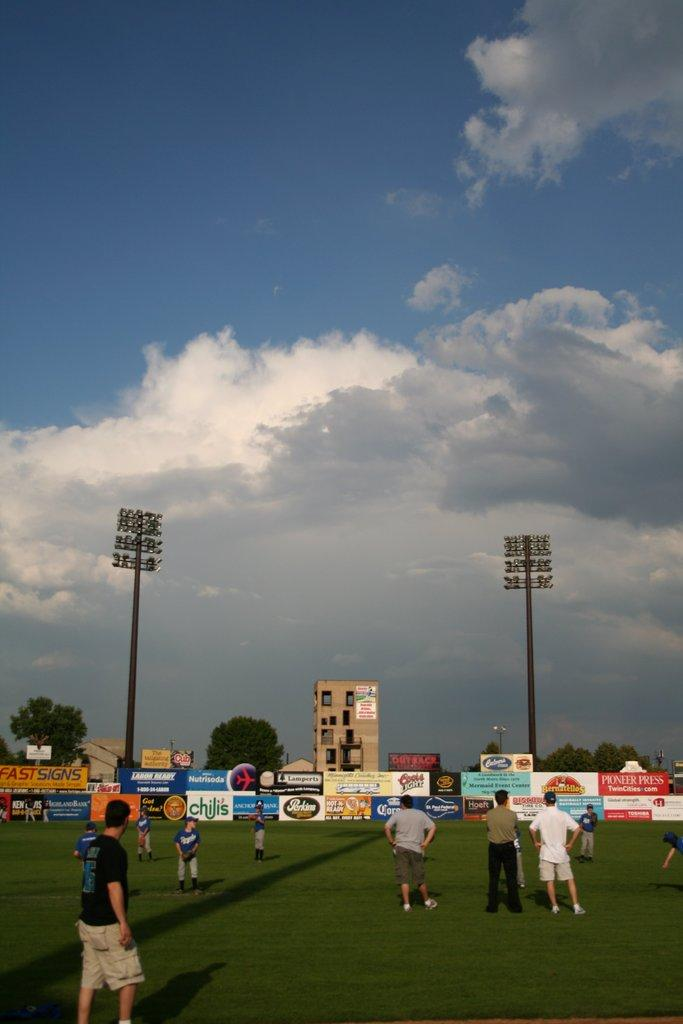What is happening with the group of people in the image? The group of people is standing on the ground. What can be seen in the background of the image? There is a building, trees, lights, and the sky visible in the background of the image. What objects are present in the image? There are boards present in the image. How does the grass increase in height during the event in the image? There is no grass present in the image, so it cannot be determined how the grass might increase in height. 